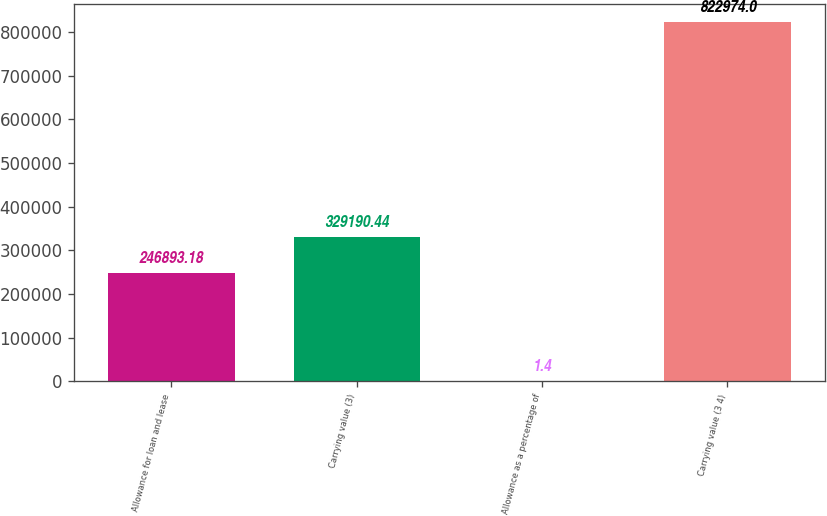Convert chart. <chart><loc_0><loc_0><loc_500><loc_500><bar_chart><fcel>Allowance for loan and lease<fcel>Carrying value (3)<fcel>Allowance as a percentage of<fcel>Carrying value (3 4)<nl><fcel>246893<fcel>329190<fcel>1.4<fcel>822974<nl></chart> 